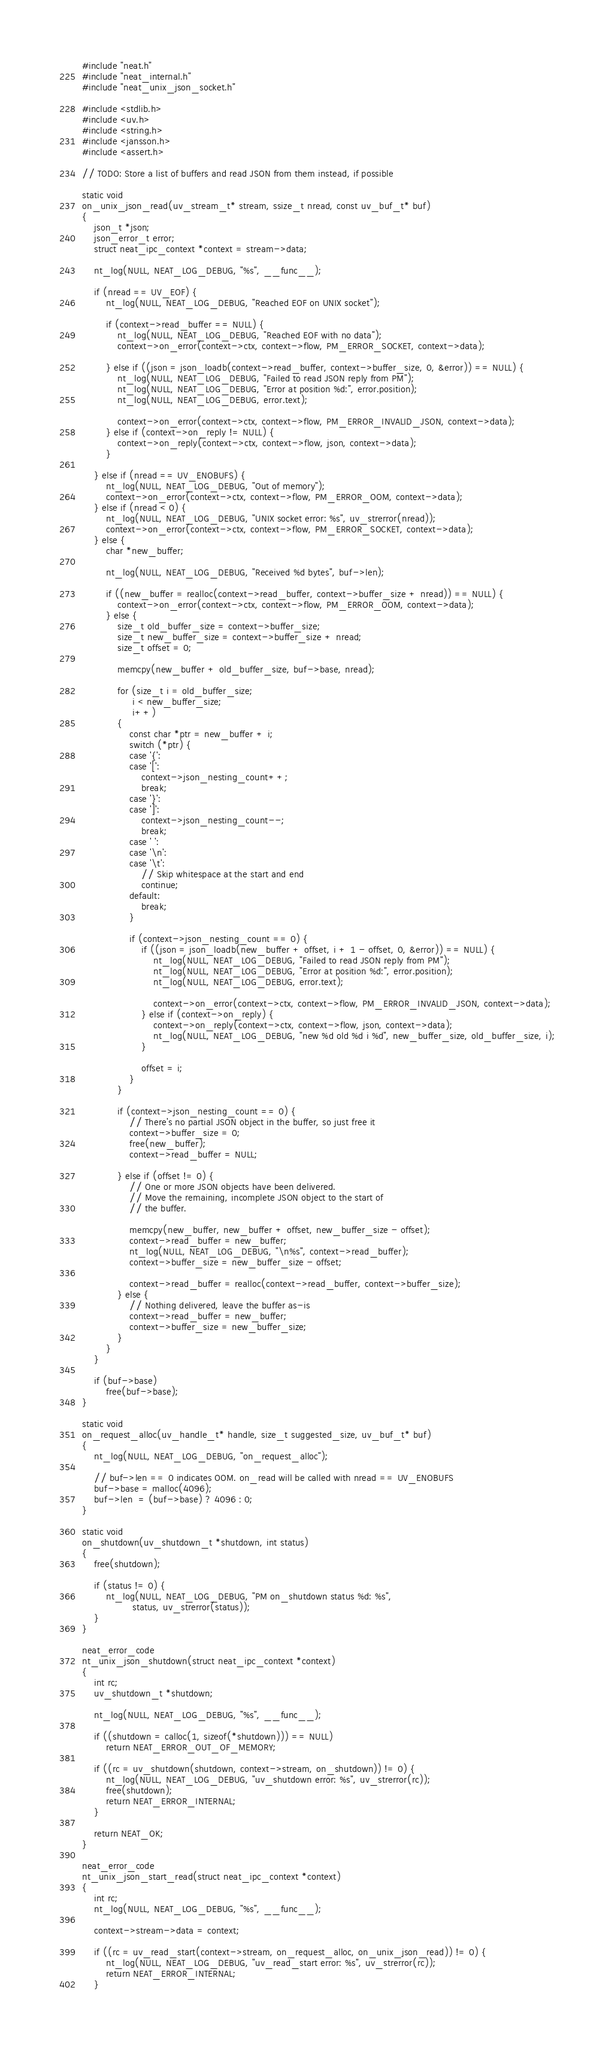Convert code to text. <code><loc_0><loc_0><loc_500><loc_500><_C_>#include "neat.h"
#include "neat_internal.h"
#include "neat_unix_json_socket.h"

#include <stdlib.h>
#include <uv.h>
#include <string.h>
#include <jansson.h>
#include <assert.h>

// TODO: Store a list of buffers and read JSON from them instead, if possible

static void
on_unix_json_read(uv_stream_t* stream, ssize_t nread, const uv_buf_t* buf)
{
    json_t *json;
    json_error_t error;
    struct neat_ipc_context *context = stream->data;

    nt_log(NULL, NEAT_LOG_DEBUG, "%s", __func__);

    if (nread == UV_EOF) {
        nt_log(NULL, NEAT_LOG_DEBUG, "Reached EOF on UNIX socket");

        if (context->read_buffer == NULL) {
            nt_log(NULL, NEAT_LOG_DEBUG, "Reached EOF with no data");
            context->on_error(context->ctx, context->flow, PM_ERROR_SOCKET, context->data);

        } else if ((json = json_loadb(context->read_buffer, context->buffer_size, 0, &error)) == NULL) {
            nt_log(NULL, NEAT_LOG_DEBUG, "Failed to read JSON reply from PM");
            nt_log(NULL, NEAT_LOG_DEBUG, "Error at position %d:", error.position);
            nt_log(NULL, NEAT_LOG_DEBUG, error.text);

            context->on_error(context->ctx, context->flow, PM_ERROR_INVALID_JSON, context->data);
        } else if (context->on_reply != NULL) {
            context->on_reply(context->ctx, context->flow, json, context->data);
        }

    } else if (nread == UV_ENOBUFS) {
        nt_log(NULL, NEAT_LOG_DEBUG, "Out of memory");
        context->on_error(context->ctx, context->flow, PM_ERROR_OOM, context->data);
    } else if (nread < 0) {
        nt_log(NULL, NEAT_LOG_DEBUG, "UNIX socket error: %s", uv_strerror(nread));
        context->on_error(context->ctx, context->flow, PM_ERROR_SOCKET, context->data);
    } else {
        char *new_buffer;

        nt_log(NULL, NEAT_LOG_DEBUG, "Received %d bytes", buf->len);

        if ((new_buffer = realloc(context->read_buffer, context->buffer_size + nread)) == NULL) {
            context->on_error(context->ctx, context->flow, PM_ERROR_OOM, context->data);
        } else {
            size_t old_buffer_size = context->buffer_size;
            size_t new_buffer_size = context->buffer_size + nread;
            size_t offset = 0;

            memcpy(new_buffer + old_buffer_size, buf->base, nread);

            for (size_t i = old_buffer_size;
                 i < new_buffer_size;
                 i++)
            {
                const char *ptr = new_buffer + i;
                switch (*ptr) {
                case '{':
                case '[':
                    context->json_nesting_count++;
                    break;
                case '}':
                case ']':
                    context->json_nesting_count--;
                    break;
                case ' ':
                case '\n':
                case '\t':
                    // Skip whitespace at the start and end
                    continue;
                default:
                    break;
                }

                if (context->json_nesting_count == 0) {
                    if ((json = json_loadb(new_buffer + offset, i + 1 - offset, 0, &error)) == NULL) {
                        nt_log(NULL, NEAT_LOG_DEBUG, "Failed to read JSON reply from PM");
                        nt_log(NULL, NEAT_LOG_DEBUG, "Error at position %d:", error.position);
                        nt_log(NULL, NEAT_LOG_DEBUG, error.text);

                        context->on_error(context->ctx, context->flow, PM_ERROR_INVALID_JSON, context->data);
                    } else if (context->on_reply) {
                        context->on_reply(context->ctx, context->flow, json, context->data);
                        nt_log(NULL, NEAT_LOG_DEBUG, "new %d old %d i %d", new_buffer_size, old_buffer_size, i);
                    }

                    offset = i;
                }
            }

            if (context->json_nesting_count == 0) {
                // There's no partial JSON object in the buffer, so just free it
                context->buffer_size = 0;
                free(new_buffer);
                context->read_buffer = NULL;

            } else if (offset != 0) {
                // One or more JSON objects have been delivered.
                // Move the remaining, incomplete JSON object to the start of
                // the buffer.

                memcpy(new_buffer, new_buffer + offset, new_buffer_size - offset);
                context->read_buffer = new_buffer;
                nt_log(NULL, NEAT_LOG_DEBUG, "\n%s", context->read_buffer);
                context->buffer_size = new_buffer_size - offset;

                context->read_buffer = realloc(context->read_buffer, context->buffer_size);
            } else {
                // Nothing delivered, leave the buffer as-is
                context->read_buffer = new_buffer;
                context->buffer_size = new_buffer_size;
            }
        }
    }

    if (buf->base)
        free(buf->base);
}

static void
on_request_alloc(uv_handle_t* handle, size_t suggested_size, uv_buf_t* buf)
{
    nt_log(NULL, NEAT_LOG_DEBUG, "on_request_alloc");

    // buf->len == 0 indicates OOM. on_read will be called with nread == UV_ENOBUFS
    buf->base = malloc(4096);
    buf->len  = (buf->base) ? 4096 : 0;
}

static void
on_shutdown(uv_shutdown_t *shutdown, int status)
{
    free(shutdown);

    if (status != 0) {
        nt_log(NULL, NEAT_LOG_DEBUG, "PM on_shutdown status %d: %s",
                 status, uv_strerror(status));
    }
}

neat_error_code
nt_unix_json_shutdown(struct neat_ipc_context *context)
{
    int rc;
    uv_shutdown_t *shutdown;

    nt_log(NULL, NEAT_LOG_DEBUG, "%s", __func__);

    if ((shutdown = calloc(1, sizeof(*shutdown))) == NULL)
        return NEAT_ERROR_OUT_OF_MEMORY;

    if ((rc = uv_shutdown(shutdown, context->stream, on_shutdown)) != 0) {
        nt_log(NULL, NEAT_LOG_DEBUG, "uv_shutdown error: %s", uv_strerror(rc));
        free(shutdown);
        return NEAT_ERROR_INTERNAL;
    }

    return NEAT_OK;
}

neat_error_code
nt_unix_json_start_read(struct neat_ipc_context *context)
{
    int rc;
    nt_log(NULL, NEAT_LOG_DEBUG, "%s", __func__);

    context->stream->data = context;

    if ((rc = uv_read_start(context->stream, on_request_alloc, on_unix_json_read)) != 0) {
        nt_log(NULL, NEAT_LOG_DEBUG, "uv_read_start error: %s", uv_strerror(rc));
        return NEAT_ERROR_INTERNAL;
    }
</code> 